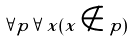Convert formula to latex. <formula><loc_0><loc_0><loc_500><loc_500>\forall p \forall x ( x \notin p )</formula> 